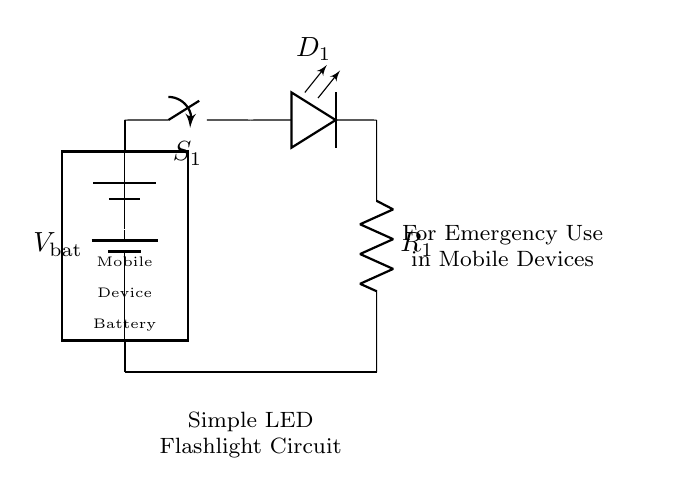What components are in this circuit? The circuit contains a battery, switch, LED, and resistor.
Answer: Battery, switch, LED, resistor What is the purpose of the switch in this circuit? The switch allows the user to control the flow of current to the LED, turning it on or off as needed.
Answer: To control the LED What is the function of the resistor in this circuit? The resistor limits the current flowing through the LED to prevent it from burning out by ensuring it operates within a safe range.
Answer: Limit current What could happen if the resistor value is too low? If the resistor value is too low, the LED may receive excessive current, which could cause it to overheat and fail, leading to a burnout.
Answer: LED burnout What is the potential difference of the battery typically used in a mobile device flashlight circuit? A common voltage for batteries in such applications is 3 to 5 volts, which is sufficient to power an LED effectively.
Answer: Three to five volts How does the LED orientation affect the circuit functionality? The LED must be correctly oriented to function; it must be connected with the anode to the positive terminal and cathode to the negative terminal, otherwise, it will not light up.
Answer: LED orientation matters In what scenario could this flashlight circuit be particularly useful? This circuit provides a simple and accessible lighting solution for emergencies when a mobile device requires illumination in dark situations, such as power outages.
Answer: Emergency lighting 